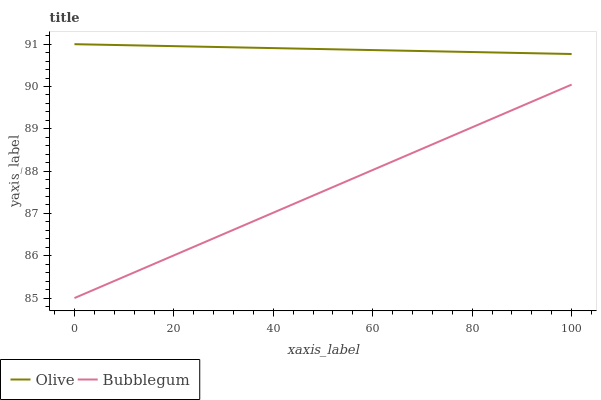Does Bubblegum have the minimum area under the curve?
Answer yes or no. Yes. Does Olive have the maximum area under the curve?
Answer yes or no. Yes. Does Bubblegum have the maximum area under the curve?
Answer yes or no. No. Is Bubblegum the smoothest?
Answer yes or no. Yes. Is Olive the roughest?
Answer yes or no. Yes. Is Bubblegum the roughest?
Answer yes or no. No. Does Bubblegum have the lowest value?
Answer yes or no. Yes. Does Olive have the highest value?
Answer yes or no. Yes. Does Bubblegum have the highest value?
Answer yes or no. No. Is Bubblegum less than Olive?
Answer yes or no. Yes. Is Olive greater than Bubblegum?
Answer yes or no. Yes. Does Bubblegum intersect Olive?
Answer yes or no. No. 